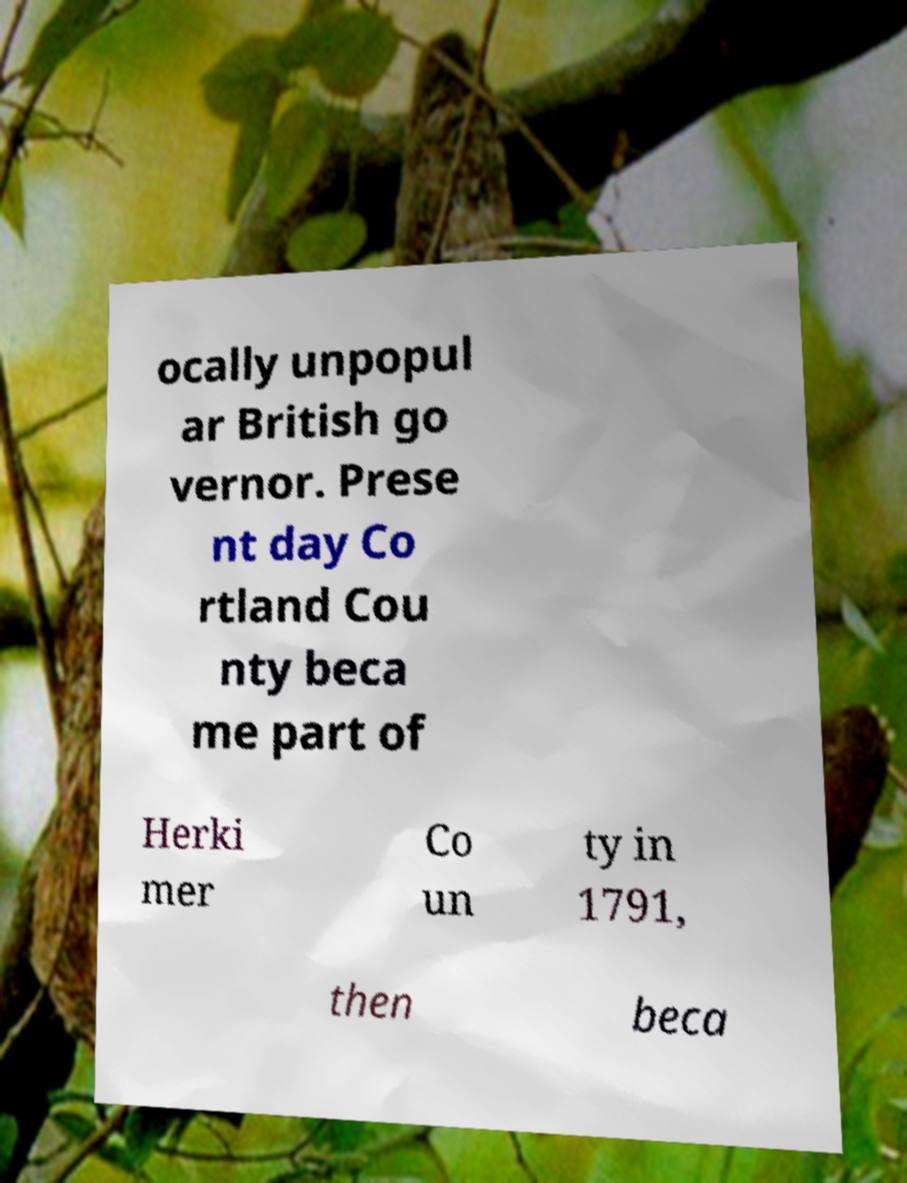Please identify and transcribe the text found in this image. ocally unpopul ar British go vernor. Prese nt day Co rtland Cou nty beca me part of Herki mer Co un ty in 1791, then beca 